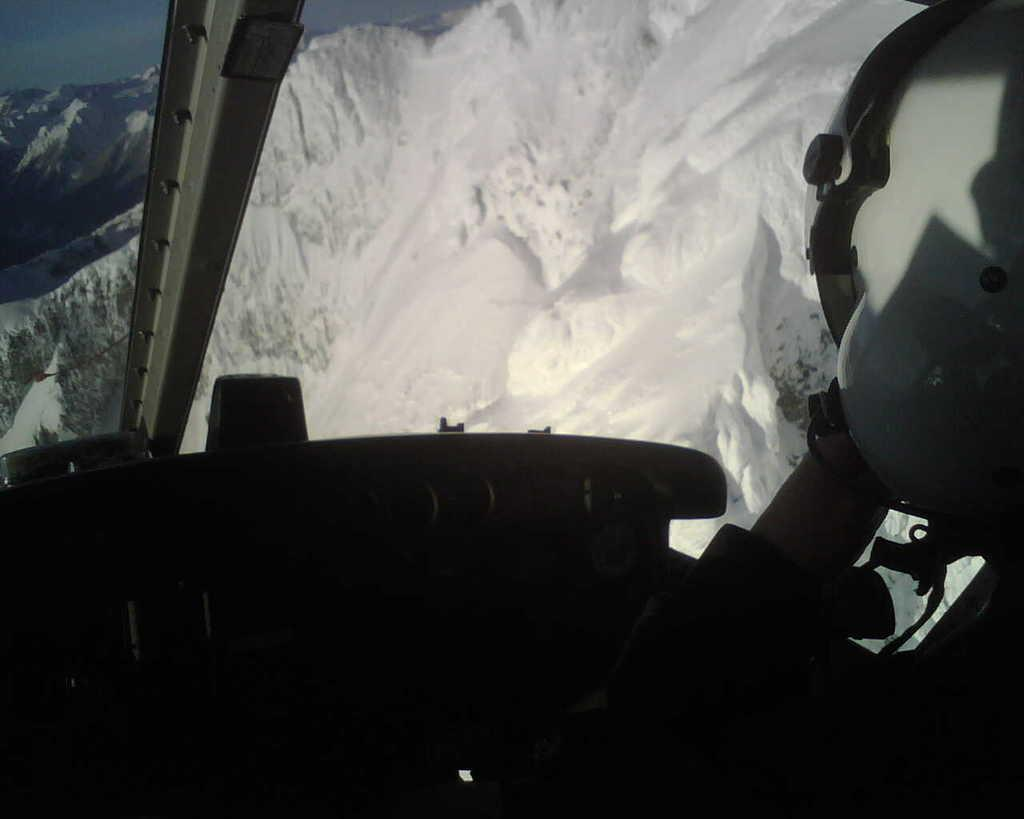Who is present in the image? There is a person in the image. What is the person wearing? The person is wearing a helmet. What is the person doing in the image? The person is sitting in a vehicle. What can be seen in the background of the image? There are mountains and the sky visible in the background of the image. What type of property does the person own in the image? There is no information about property ownership in the image. What credit card is the person using in the image? There is no credit card or financial transaction depicted in the image. 